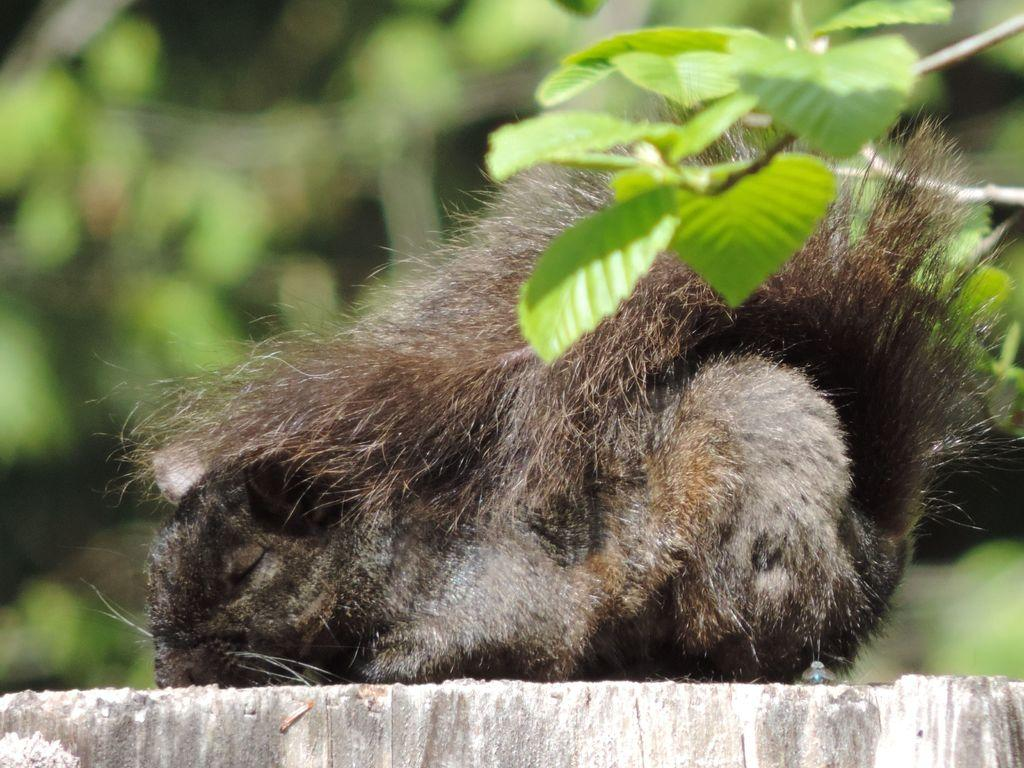What type of creature is in the image? There is an animal in the image. Can you describe the color pattern of the animal? The animal is brown and white in color. What type of vegetation can be seen in the image? There are leaves visible in the image. How would you describe the background of the image? The background of the image is blurred. What type of system is the animal using to stop its movement in the image? There is no indication in the image that the animal is moving or using a system to stop its movement. 